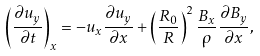<formula> <loc_0><loc_0><loc_500><loc_500>\left ( \frac { \partial u _ { y } } { \partial t } \right ) _ { x } = - u _ { x } \frac { \partial u _ { y } } { \partial x } + \left ( \frac { R _ { 0 } } { R } \right ) ^ { 2 } \frac { B _ { x } } { \rho } \frac { \partial B _ { y } } { \partial x } ,</formula> 